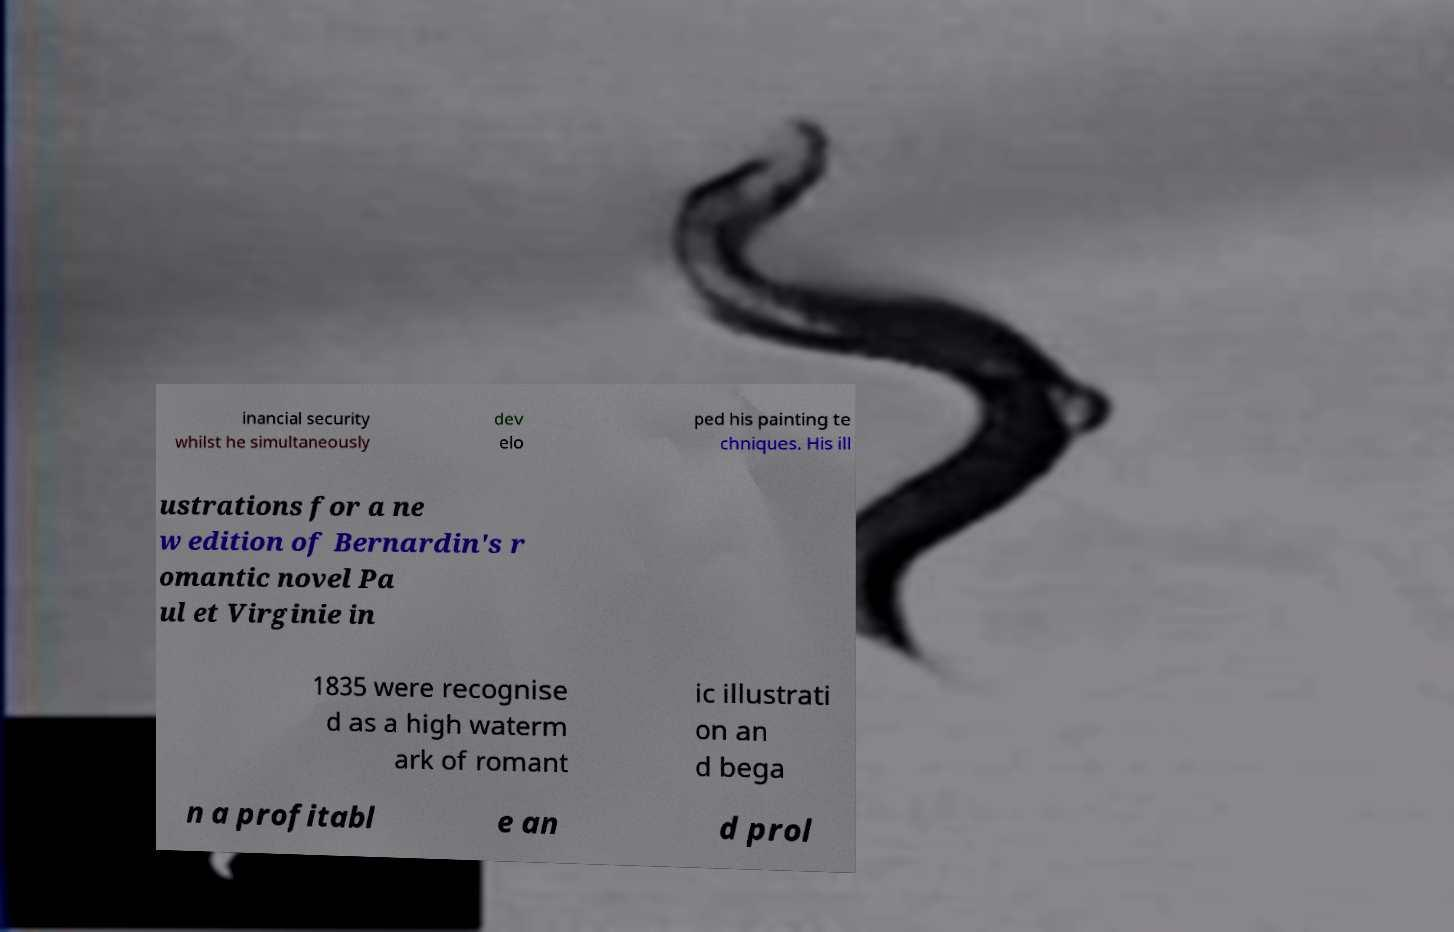Can you read and provide the text displayed in the image?This photo seems to have some interesting text. Can you extract and type it out for me? inancial security whilst he simultaneously dev elo ped his painting te chniques. His ill ustrations for a ne w edition of Bernardin's r omantic novel Pa ul et Virginie in 1835 were recognise d as a high waterm ark of romant ic illustrati on an d bega n a profitabl e an d prol 